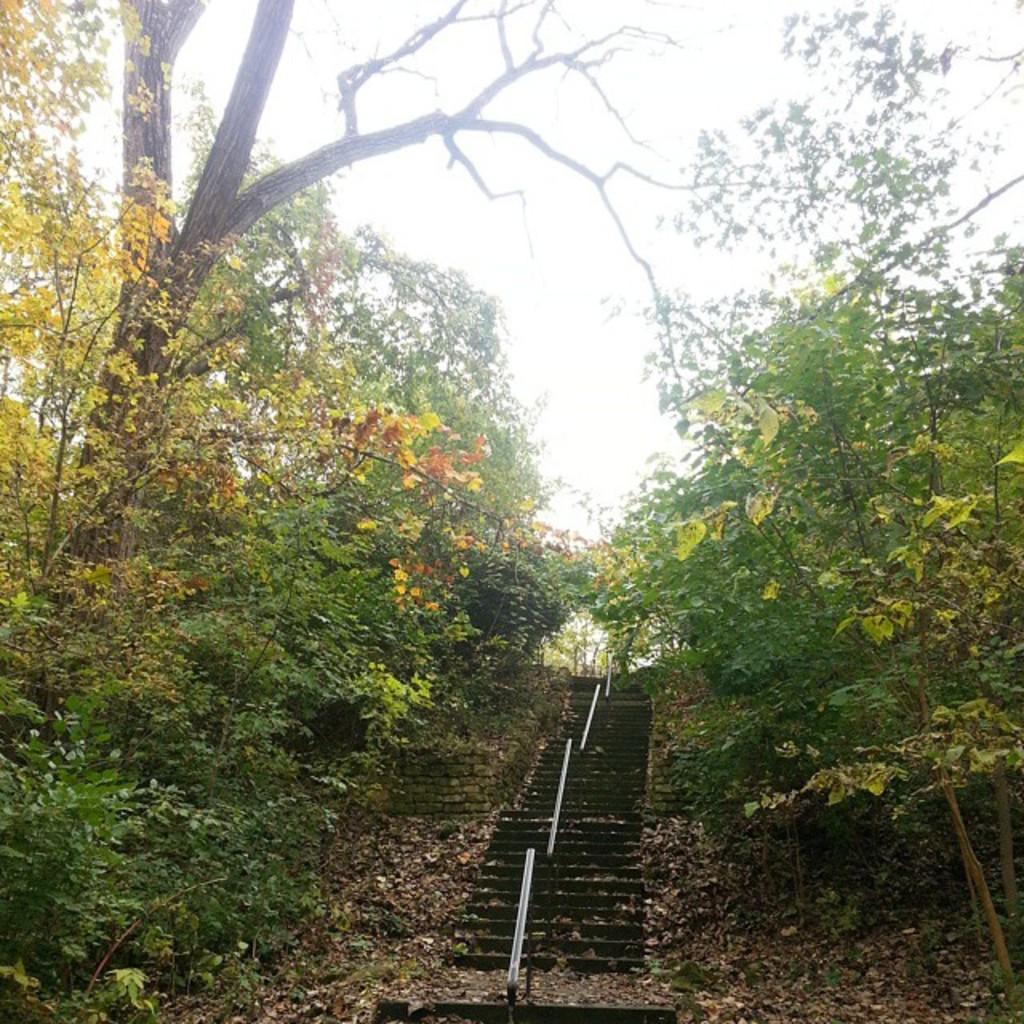How would you summarize this image in a sentence or two? On the left side of the image and right side of the image there are trees. In the middle of the image I can see dried leaves and stems. In the background of the image there is a sky. 